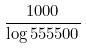<formula> <loc_0><loc_0><loc_500><loc_500>\frac { 1 0 0 0 } { \log 5 5 5 5 0 0 }</formula> 